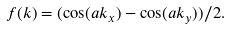Convert formula to latex. <formula><loc_0><loc_0><loc_500><loc_500>f ( k ) = ( \cos ( a k _ { x } ) - \cos ( a k _ { y } ) ) / 2 .</formula> 